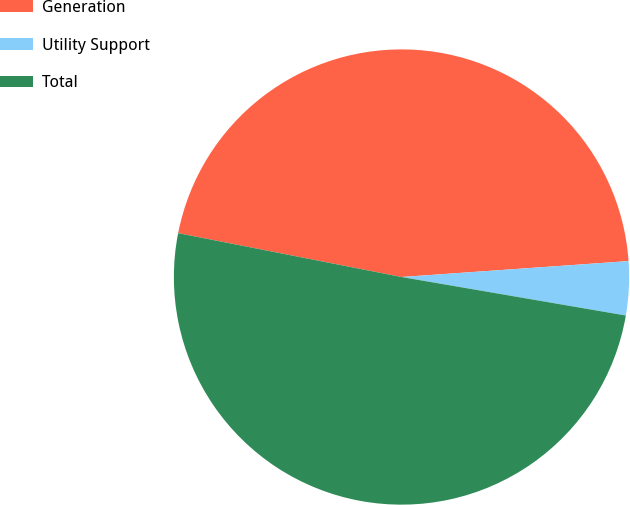<chart> <loc_0><loc_0><loc_500><loc_500><pie_chart><fcel>Generation<fcel>Utility Support<fcel>Total<nl><fcel>45.8%<fcel>3.82%<fcel>50.38%<nl></chart> 